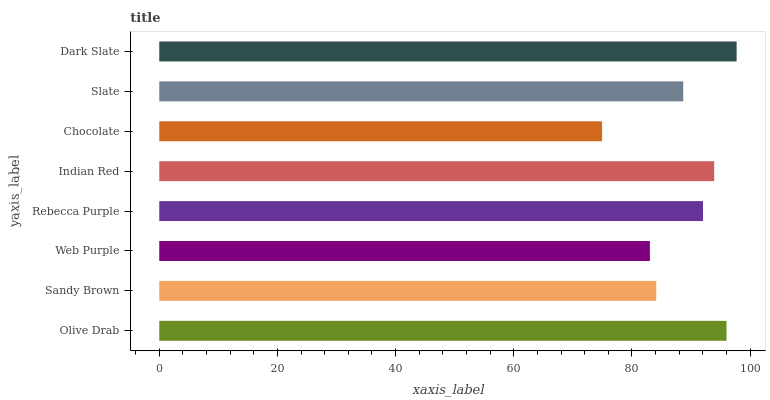Is Chocolate the minimum?
Answer yes or no. Yes. Is Dark Slate the maximum?
Answer yes or no. Yes. Is Sandy Brown the minimum?
Answer yes or no. No. Is Sandy Brown the maximum?
Answer yes or no. No. Is Olive Drab greater than Sandy Brown?
Answer yes or no. Yes. Is Sandy Brown less than Olive Drab?
Answer yes or no. Yes. Is Sandy Brown greater than Olive Drab?
Answer yes or no. No. Is Olive Drab less than Sandy Brown?
Answer yes or no. No. Is Rebecca Purple the high median?
Answer yes or no. Yes. Is Slate the low median?
Answer yes or no. Yes. Is Olive Drab the high median?
Answer yes or no. No. Is Chocolate the low median?
Answer yes or no. No. 